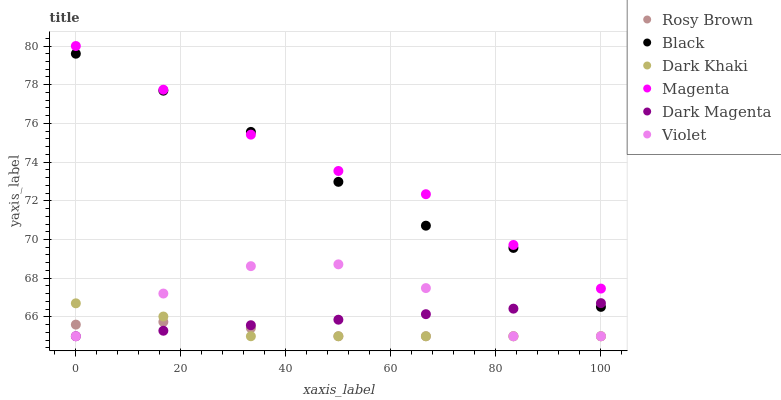Does Rosy Brown have the minimum area under the curve?
Answer yes or no. Yes. Does Magenta have the maximum area under the curve?
Answer yes or no. Yes. Does Dark Khaki have the minimum area under the curve?
Answer yes or no. No. Does Dark Khaki have the maximum area under the curve?
Answer yes or no. No. Is Dark Magenta the smoothest?
Answer yes or no. Yes. Is Violet the roughest?
Answer yes or no. Yes. Is Rosy Brown the smoothest?
Answer yes or no. No. Is Rosy Brown the roughest?
Answer yes or no. No. Does Dark Magenta have the lowest value?
Answer yes or no. Yes. Does Black have the lowest value?
Answer yes or no. No. Does Magenta have the highest value?
Answer yes or no. Yes. Does Dark Khaki have the highest value?
Answer yes or no. No. Is Dark Magenta less than Magenta?
Answer yes or no. Yes. Is Magenta greater than Rosy Brown?
Answer yes or no. Yes. Does Black intersect Dark Magenta?
Answer yes or no. Yes. Is Black less than Dark Magenta?
Answer yes or no. No. Is Black greater than Dark Magenta?
Answer yes or no. No. Does Dark Magenta intersect Magenta?
Answer yes or no. No. 